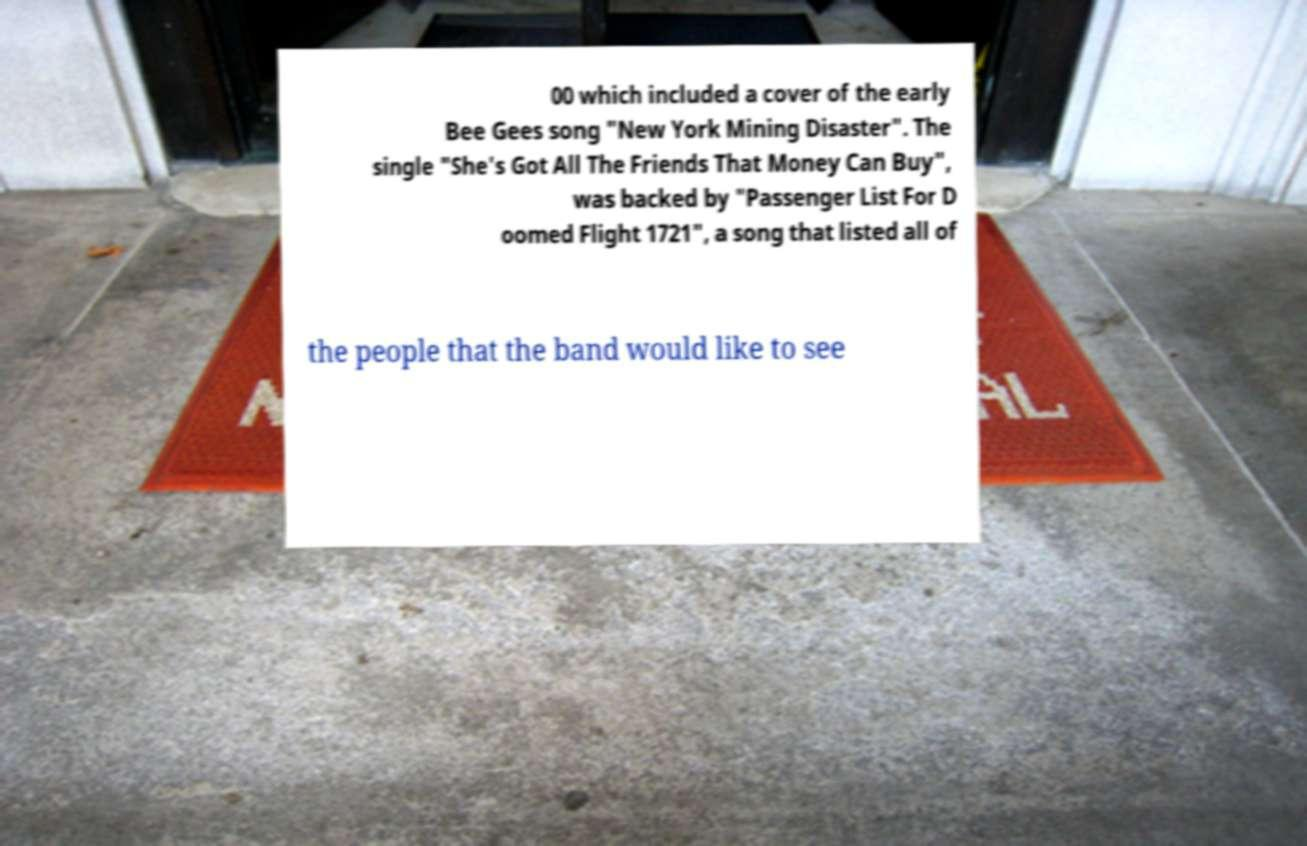Please read and relay the text visible in this image. What does it say? 00 which included a cover of the early Bee Gees song "New York Mining Disaster". The single "She's Got All The Friends That Money Can Buy", was backed by "Passenger List For D oomed Flight 1721", a song that listed all of the people that the band would like to see 